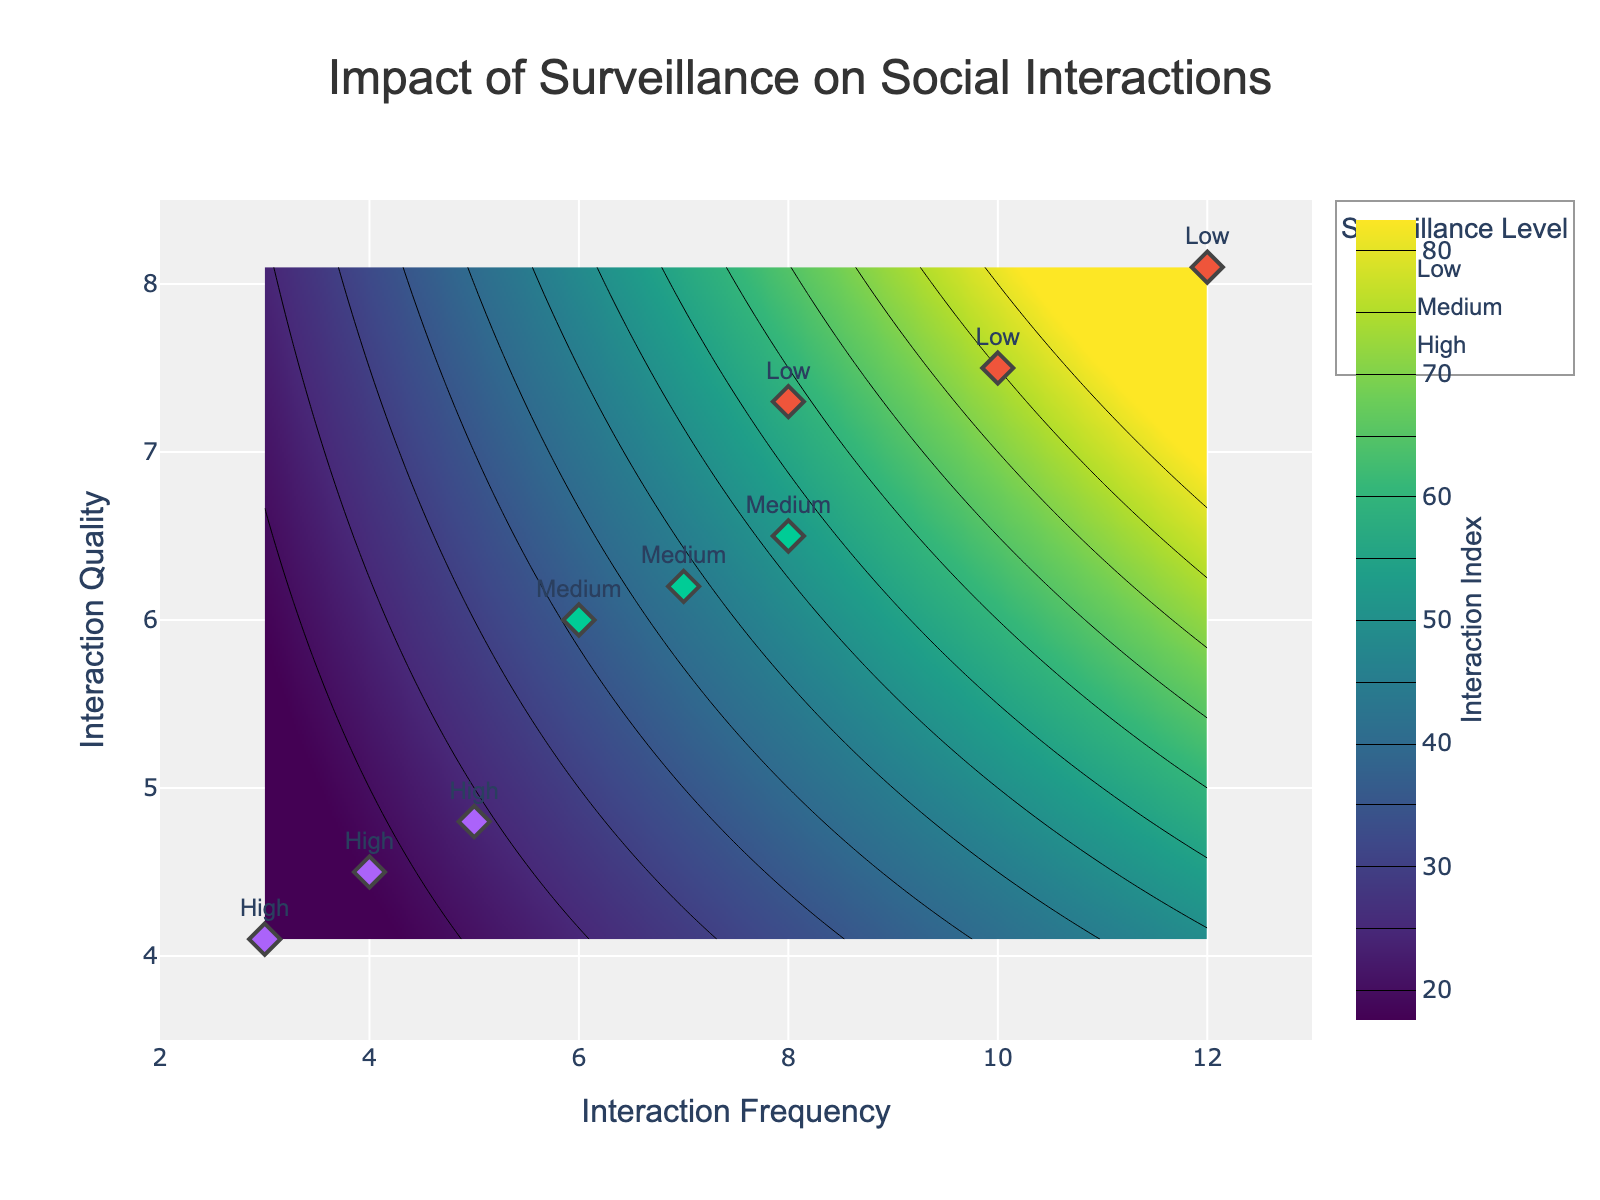What's the title of the figure? The title is displayed at the top of the figure. Looking at the plot, we see the text that indicates the title.
Answer: Impact of Surveillance on Social Interactions How many surveillance levels are included in the figure? We need to look at the legend, which shows the different surveillance levels marked by different symbols.
Answer: 3 What are the x and y axis labels? The x-axis label is typically on the horizontal axis, and the y-axis label is on the vertical axis. According to the plot's labels, they can be identified.
Answer: Interaction Frequency and Interaction Quality Which surveillance level has the data points with the lowest interaction frequency and quality? By examining the scatter plot and checking the labels next to the points, we can identify which surveillance level corresponds to the lowest values in both axes. The high surveillance level points are clustered around the lowest interaction frequency and quality values.
Answer: High Which color palette is used for the contour plot? The color palette for the contour plot is usually indicated by the color scale on the figure. For this plot, we notice a range of colors indicating the heatmap created by the contour lines.
Answer: Viridis What is the range of the interaction frequency axis? To determine the range, we look at the minimum and maximum values indicated on the x-axis.
Answer: 2 to 13 What is the overall trend between surveillance level and interaction quality according to the scatter plot? We can identify the trend by observing the clustering of points and the general direction as the surveillance level changes from Low to High. Low surveillance levels are associated with higher interaction quality, and as surveillance increases, interaction quality decreases.
Answer: Interaction quality tends to decrease with higher surveillance levels Calculate the average interaction quality for the low surveillance level. To find the average, we sum the interaction quality values for low surveillance and divide by the number of points: (7.5 + 8.1 + 7.3)/3.
Answer: 7.63 Compare the average interaction frequency of low surveillance to high surveillance. Calculate the average for both: Low: (10 + 12 + 8)/3 = 10; High: (5 + 4 + 3)/3 = 4; Then compare them.
Answer: Low is greater than high by 6 Which surveillance level has the highest variation in interaction quality? By observing the spread of the points, we look for the surveillance level where points are the most spread out vertically. Low surveillance level shows the highest variation in interaction quality as the range is from 7.3 to 8.1.
Answer: Low 